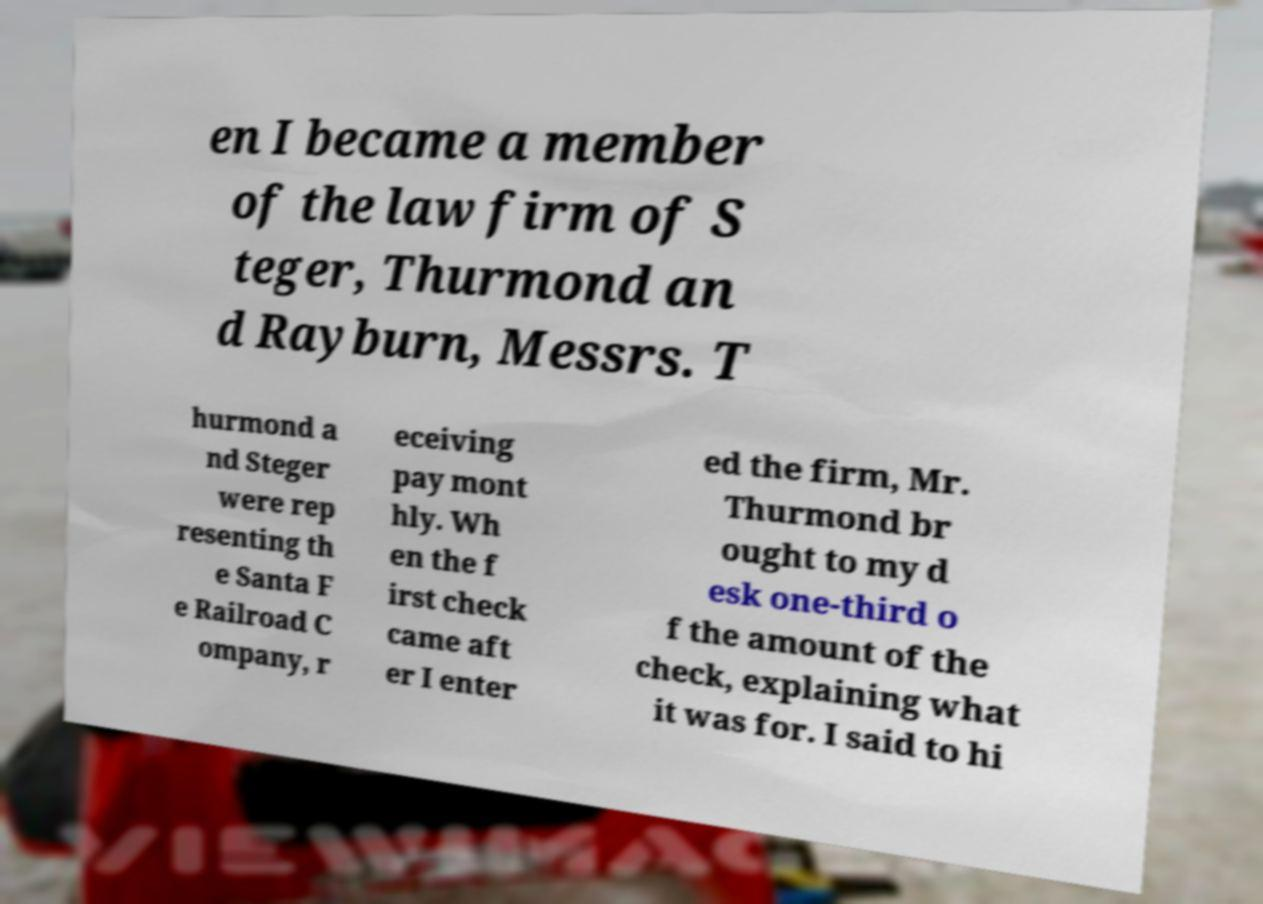Could you assist in decoding the text presented in this image and type it out clearly? en I became a member of the law firm of S teger, Thurmond an d Rayburn, Messrs. T hurmond a nd Steger were rep resenting th e Santa F e Railroad C ompany, r eceiving pay mont hly. Wh en the f irst check came aft er I enter ed the firm, Mr. Thurmond br ought to my d esk one-third o f the amount of the check, explaining what it was for. I said to hi 